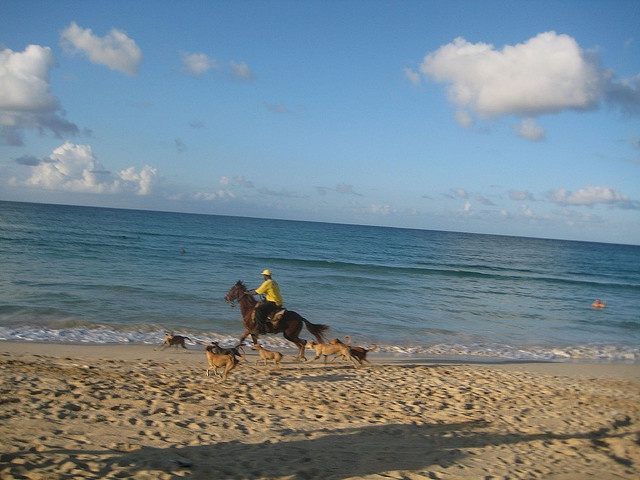Describe the objects in this image and their specific colors. I can see horse in gray, black, and maroon tones, people in gray, black, and olive tones, dog in gray and tan tones, dog in gray, olive, tan, and maroon tones, and dog in gray, black, and tan tones in this image. 